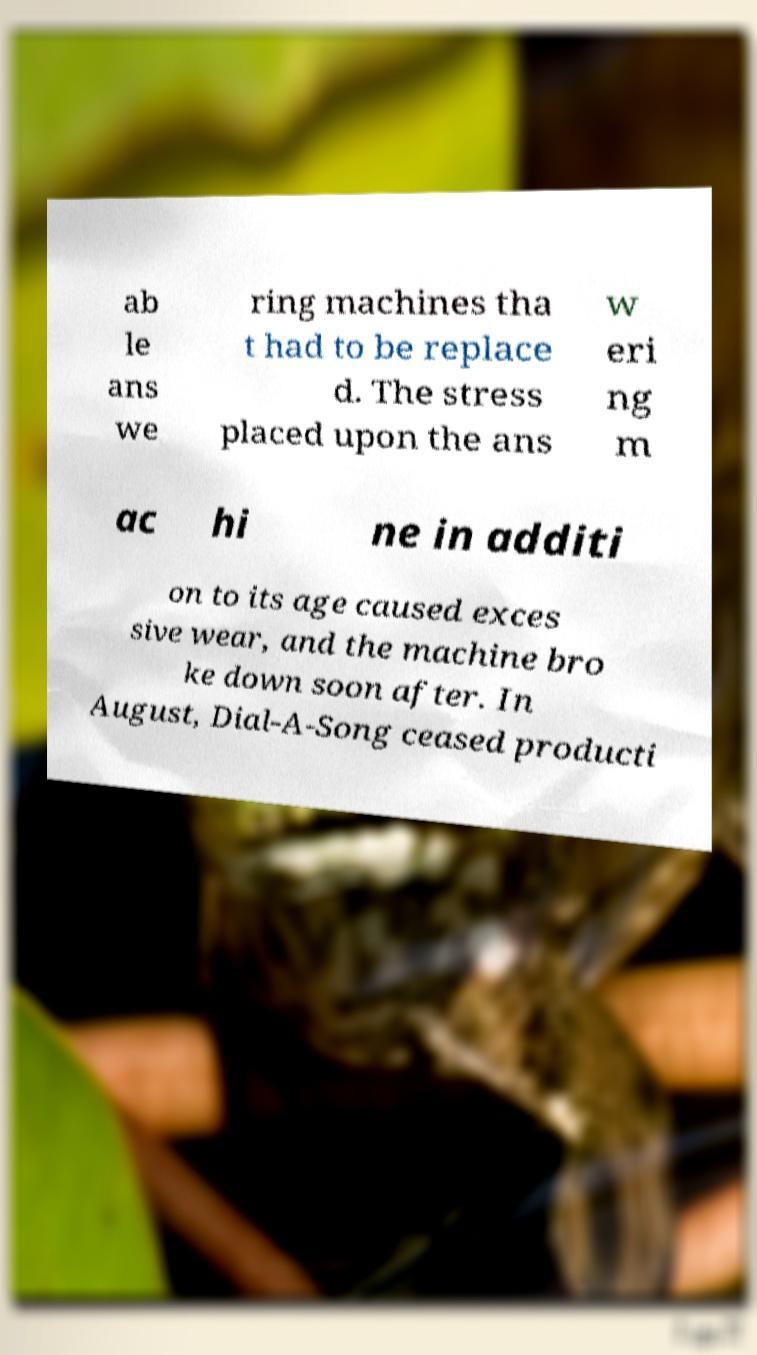I need the written content from this picture converted into text. Can you do that? ab le ans we ring machines tha t had to be replace d. The stress placed upon the ans w eri ng m ac hi ne in additi on to its age caused exces sive wear, and the machine bro ke down soon after. In August, Dial-A-Song ceased producti 